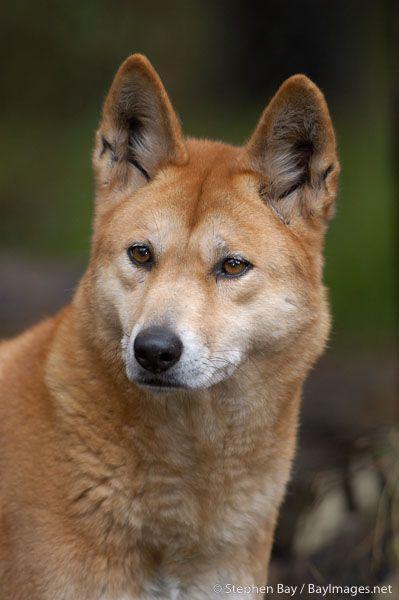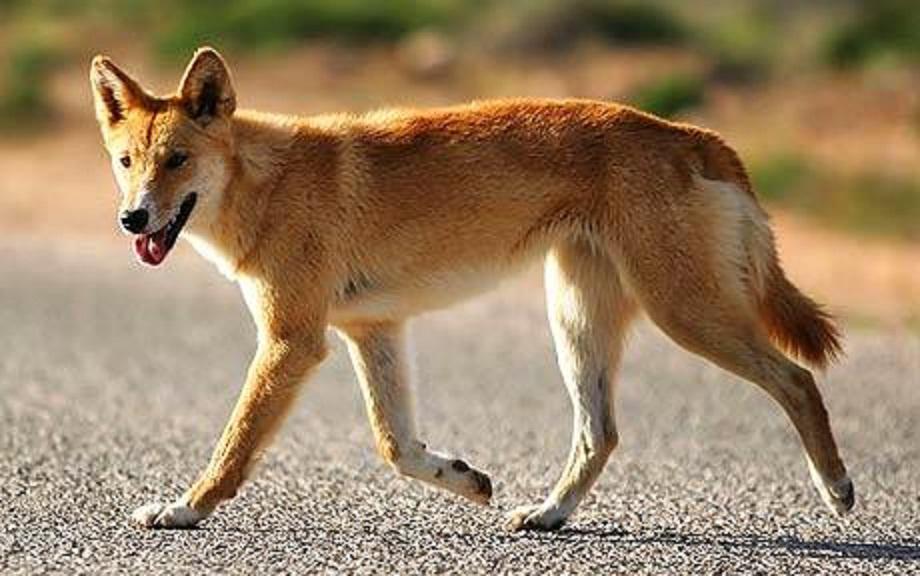The first image is the image on the left, the second image is the image on the right. For the images displayed, is the sentence "There's a total of 4 dogs on both images." factually correct? Answer yes or no. No. 